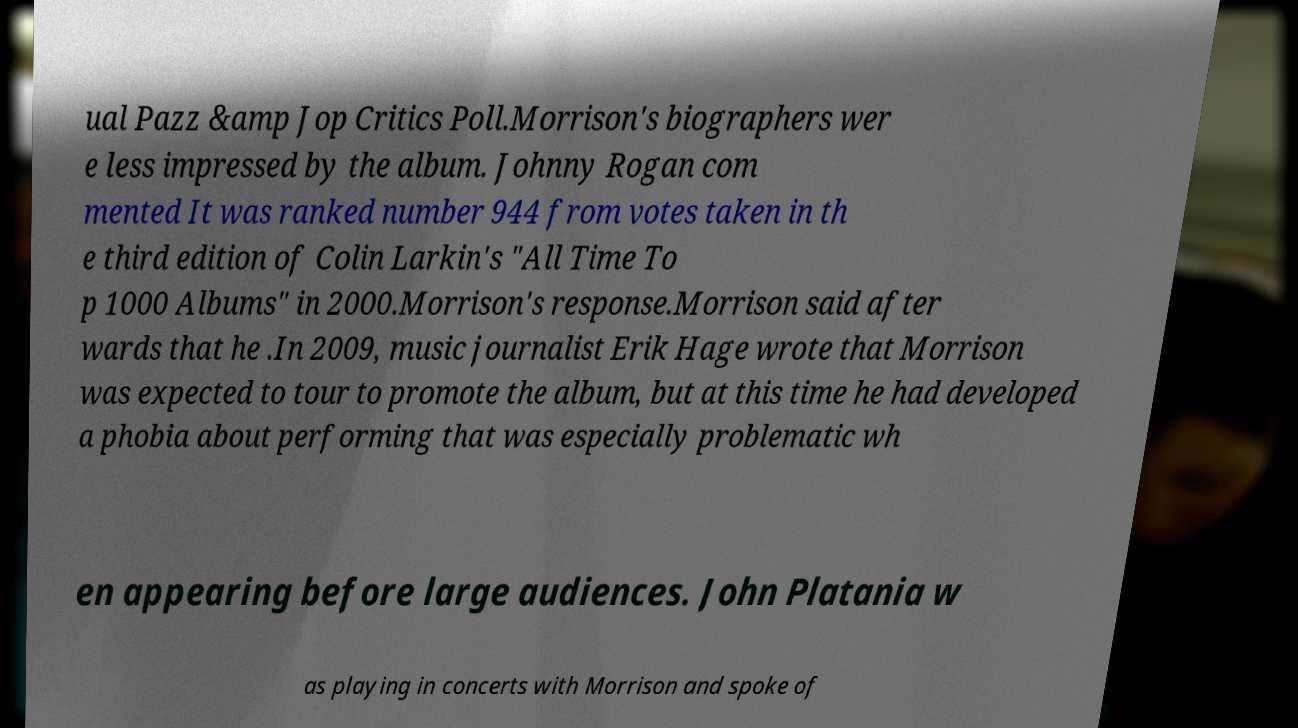Please read and relay the text visible in this image. What does it say? ual Pazz &amp Jop Critics Poll.Morrison's biographers wer e less impressed by the album. Johnny Rogan com mented It was ranked number 944 from votes taken in th e third edition of Colin Larkin's "All Time To p 1000 Albums" in 2000.Morrison's response.Morrison said after wards that he .In 2009, music journalist Erik Hage wrote that Morrison was expected to tour to promote the album, but at this time he had developed a phobia about performing that was especially problematic wh en appearing before large audiences. John Platania w as playing in concerts with Morrison and spoke of 